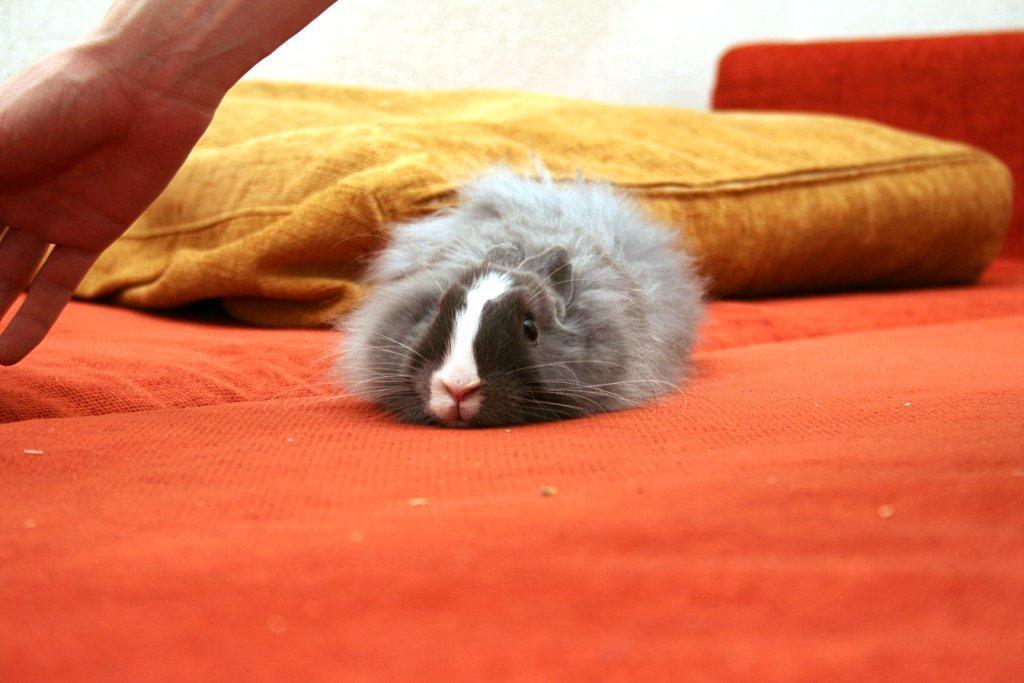Describe this image in one or two sentences. In this image there is a couch truncated towards the bottom of the image, there is a pillow on the couch, there is an animal on the couch, there is a person's hand truncated towards the top of the image, at the background of the image there is a wall truncated. 